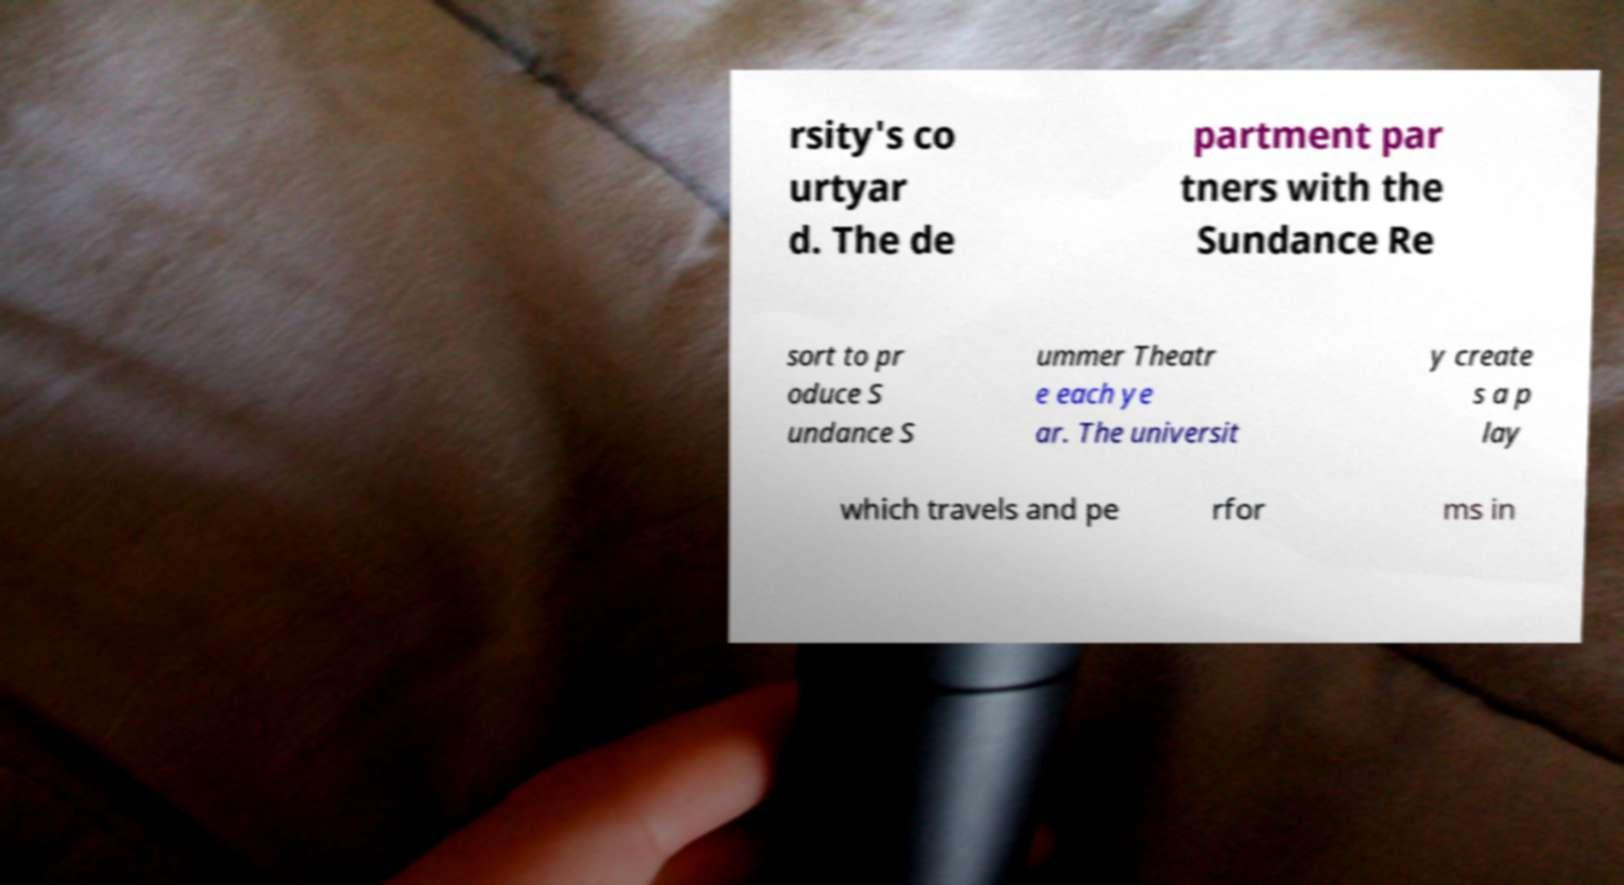I need the written content from this picture converted into text. Can you do that? rsity's co urtyar d. The de partment par tners with the Sundance Re sort to pr oduce S undance S ummer Theatr e each ye ar. The universit y create s a p lay which travels and pe rfor ms in 